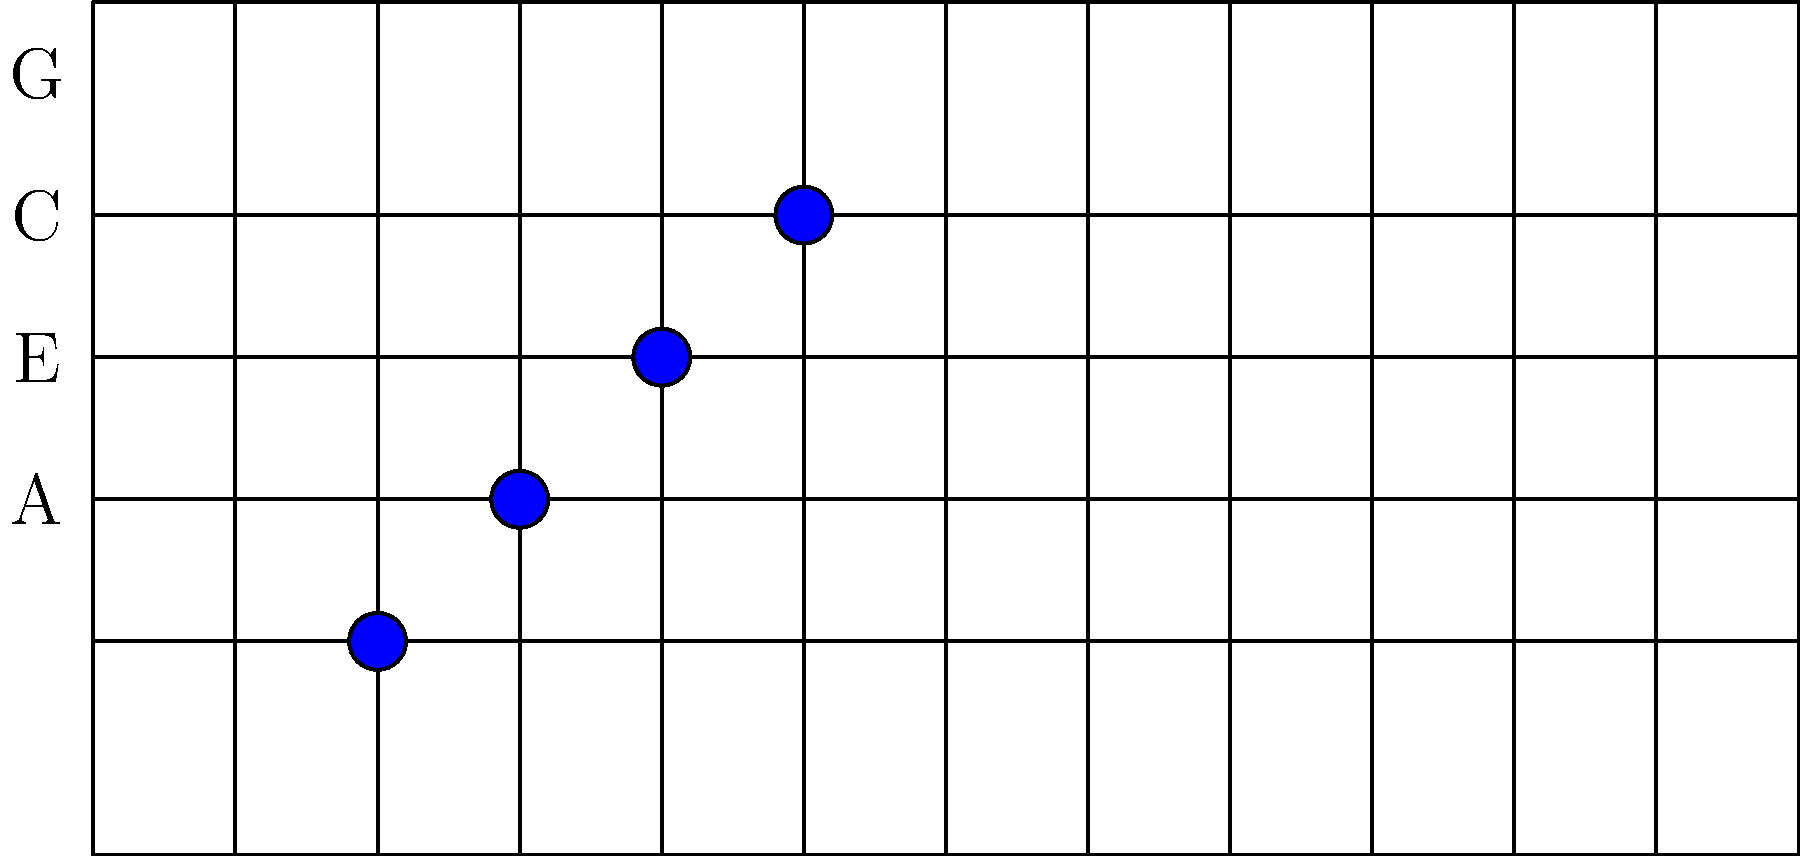Identify the scale represented by the finger positions shown on the ukulele fretboard diagram. Which fundamental music theory concept does this scale pattern demonstrate? To identify the scale and the fundamental music theory concept, let's analyze the diagram step-by-step:

1. The diagram shows a ukulele fretboard with four strings (G, C, E, A from top to bottom).

2. Blue dots indicate finger positions on the fretboard:
   - 2nd fret on the G string
   - 3rd fret on the C string
   - 4th fret on the E string
   - 5th fret on the A string

3. These finger positions represent the notes:
   - G string: A (2nd fret)
   - C string: D (3rd fret)
   - E string: G (4th fret)
   - A string: D (5th fret)

4. The sequence of notes is: A, D, G, D

5. This pattern represents a major chord shape, specifically the D major chord (D, F#, A).

6. The fundamental music theory concept demonstrated here is the chord construction using the 1-5-1 pattern:
   - Root (D on the A string)
   - Fifth (A on the G string)
   - Root an octave higher (D on the C string)
   - Third (F# implied by the G on the E string, as the ukulele's re-entrant tuning means this G is an octave higher than expected)

7. This 1-5-1 pattern is a common fingering for major chords on the ukulele, allowing for a full, rich sound while being relatively easy to play.
Answer: D major chord; 1-5-1 chord construction pattern 